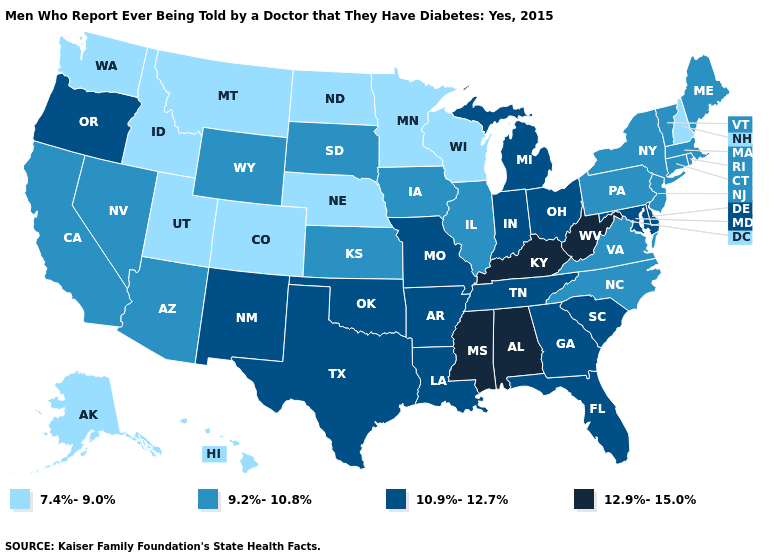Does New Hampshire have the lowest value in the USA?
Be succinct. Yes. What is the value of West Virginia?
Answer briefly. 12.9%-15.0%. How many symbols are there in the legend?
Write a very short answer. 4. Name the states that have a value in the range 10.9%-12.7%?
Keep it brief. Arkansas, Delaware, Florida, Georgia, Indiana, Louisiana, Maryland, Michigan, Missouri, New Mexico, Ohio, Oklahoma, Oregon, South Carolina, Tennessee, Texas. What is the value of Michigan?
Concise answer only. 10.9%-12.7%. Does New Hampshire have the lowest value in the USA?
Keep it brief. Yes. Name the states that have a value in the range 7.4%-9.0%?
Give a very brief answer. Alaska, Colorado, Hawaii, Idaho, Minnesota, Montana, Nebraska, New Hampshire, North Dakota, Utah, Washington, Wisconsin. Does Colorado have the lowest value in the USA?
Answer briefly. Yes. What is the highest value in the West ?
Quick response, please. 10.9%-12.7%. What is the value of Washington?
Give a very brief answer. 7.4%-9.0%. What is the lowest value in states that border Montana?
Quick response, please. 7.4%-9.0%. Name the states that have a value in the range 7.4%-9.0%?
Answer briefly. Alaska, Colorado, Hawaii, Idaho, Minnesota, Montana, Nebraska, New Hampshire, North Dakota, Utah, Washington, Wisconsin. Name the states that have a value in the range 9.2%-10.8%?
Be succinct. Arizona, California, Connecticut, Illinois, Iowa, Kansas, Maine, Massachusetts, Nevada, New Jersey, New York, North Carolina, Pennsylvania, Rhode Island, South Dakota, Vermont, Virginia, Wyoming. What is the value of Florida?
Answer briefly. 10.9%-12.7%. What is the value of Iowa?
Short answer required. 9.2%-10.8%. 